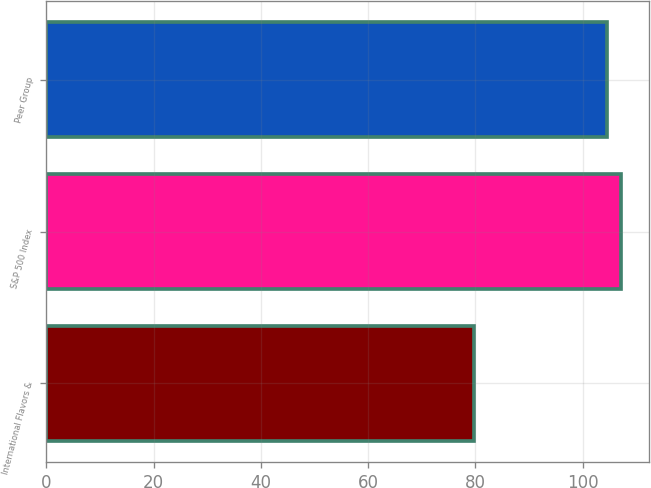Convert chart. <chart><loc_0><loc_0><loc_500><loc_500><bar_chart><fcel>International Flavors &<fcel>S&P 500 Index<fcel>Peer Group<nl><fcel>79.79<fcel>107.09<fcel>104.58<nl></chart> 